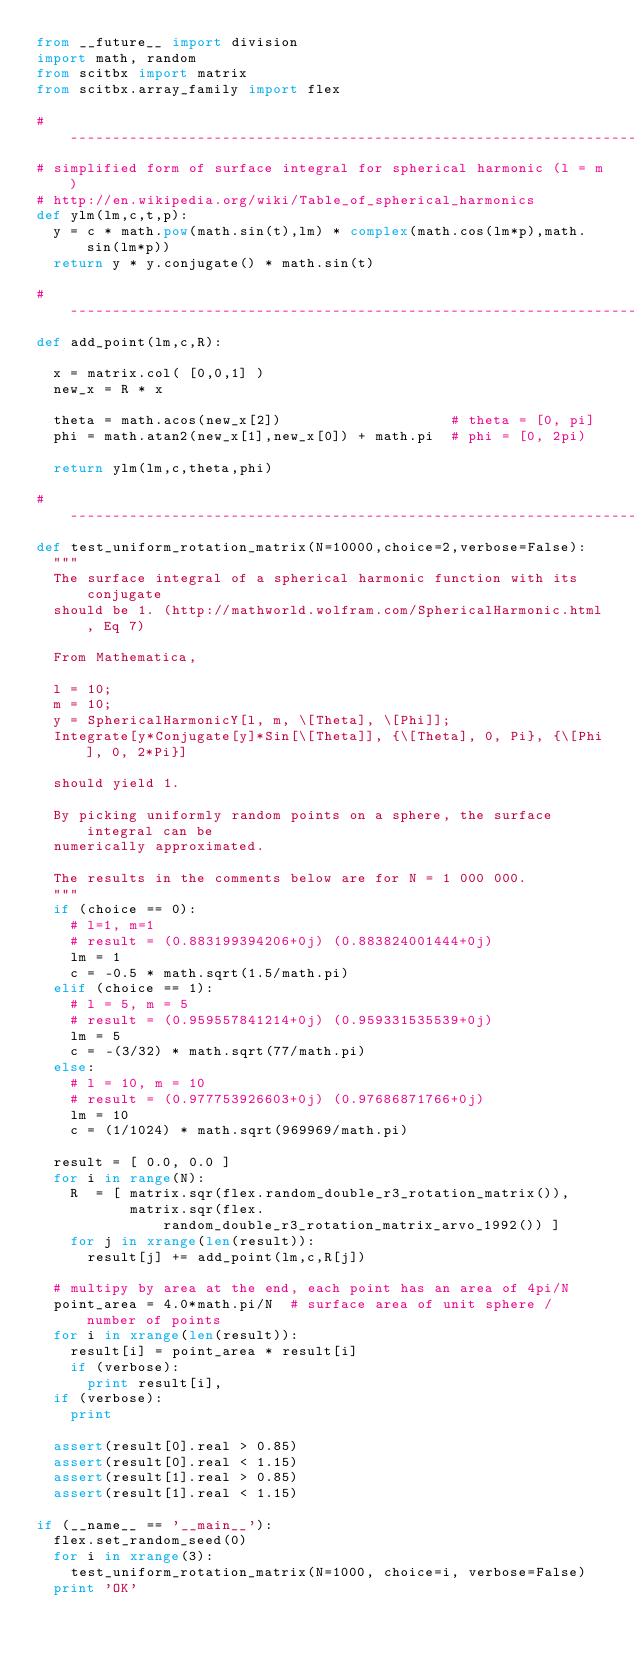Convert code to text. <code><loc_0><loc_0><loc_500><loc_500><_Python_>from __future__ import division
import math, random
from scitbx import matrix
from scitbx.array_family import flex

# -----------------------------------------------------------------------------
# simplified form of surface integral for spherical harmonic (l = m)
# http://en.wikipedia.org/wiki/Table_of_spherical_harmonics
def ylm(lm,c,t,p):
  y = c * math.pow(math.sin(t),lm) * complex(math.cos(lm*p),math.sin(lm*p))
  return y * y.conjugate() * math.sin(t)

# -----------------------------------------------------------------------------
def add_point(lm,c,R):

  x = matrix.col( [0,0,1] )
  new_x = R * x

  theta = math.acos(new_x[2])                    # theta = [0, pi]
  phi = math.atan2(new_x[1],new_x[0]) + math.pi  # phi = [0, 2pi)

  return ylm(lm,c,theta,phi)

# -----------------------------------------------------------------------------
def test_uniform_rotation_matrix(N=10000,choice=2,verbose=False):
  """
  The surface integral of a spherical harmonic function with its conjugate
  should be 1. (http://mathworld.wolfram.com/SphericalHarmonic.html, Eq 7)

  From Mathematica,

  l = 10;
  m = 10;
  y = SphericalHarmonicY[l, m, \[Theta], \[Phi]];
  Integrate[y*Conjugate[y]*Sin[\[Theta]], {\[Theta], 0, Pi}, {\[Phi], 0, 2*Pi}]

  should yield 1.

  By picking uniformly random points on a sphere, the surface integral can be
  numerically approximated.

  The results in the comments below are for N = 1 000 000.
  """
  if (choice == 0):
    # l=1, m=1
    # result = (0.883199394206+0j) (0.883824001444+0j)
    lm = 1
    c = -0.5 * math.sqrt(1.5/math.pi)
  elif (choice == 1):
    # l = 5, m = 5
    # result = (0.959557841214+0j) (0.959331535539+0j)
    lm = 5
    c = -(3/32) * math.sqrt(77/math.pi)
  else:
    # l = 10, m = 10
    # result = (0.977753926603+0j) (0.97686871766+0j)
    lm = 10
    c = (1/1024) * math.sqrt(969969/math.pi)

  result = [ 0.0, 0.0 ]
  for i in range(N):
    R  = [ matrix.sqr(flex.random_double_r3_rotation_matrix()),
           matrix.sqr(flex.random_double_r3_rotation_matrix_arvo_1992()) ]
    for j in xrange(len(result)):
      result[j] += add_point(lm,c,R[j])

  # multipy by area at the end, each point has an area of 4pi/N
  point_area = 4.0*math.pi/N  # surface area of unit sphere / number of points
  for i in xrange(len(result)):
    result[i] = point_area * result[i]
    if (verbose):
      print result[i],
  if (verbose):
    print

  assert(result[0].real > 0.85)
  assert(result[0].real < 1.15)
  assert(result[1].real > 0.85)
  assert(result[1].real < 1.15)

if (__name__ == '__main__'):
  flex.set_random_seed(0)
  for i in xrange(3):
    test_uniform_rotation_matrix(N=1000, choice=i, verbose=False)
  print 'OK'
</code> 